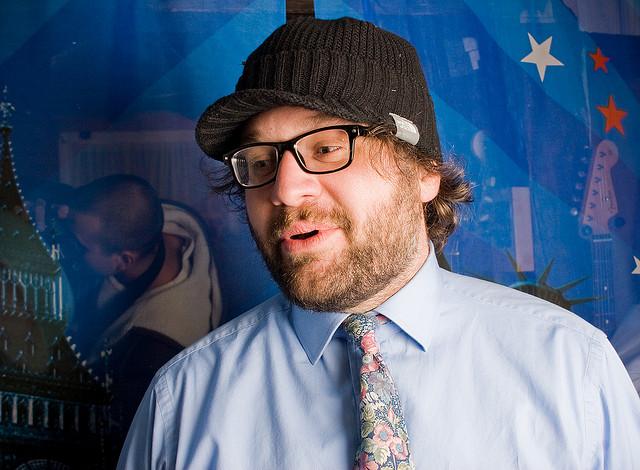What color is the man's shirt?
Answer briefly. Blue. How many men are there?
Quick response, please. 1. Is the man wearing a hat?
Be succinct. Yes. Does the man have facial hair?
Write a very short answer. Yes. What color is the man's tie?
Give a very brief answer. Floral. 